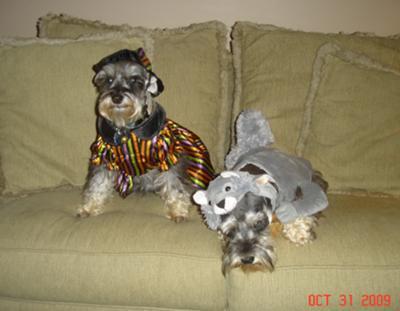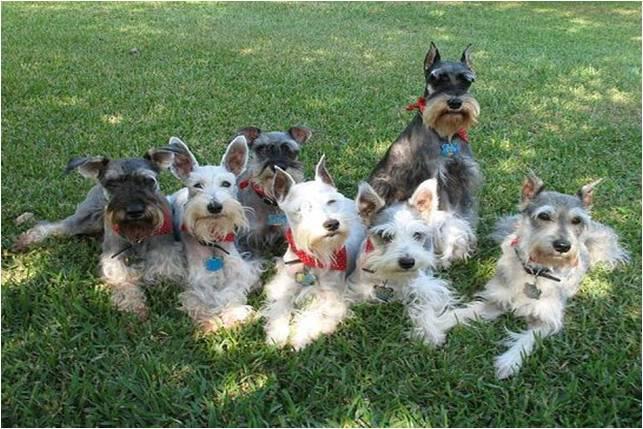The first image is the image on the left, the second image is the image on the right. Analyze the images presented: Is the assertion "A group of dogs is in the green grass in the image on the right." valid? Answer yes or no. Yes. The first image is the image on the left, the second image is the image on the right. Analyze the images presented: Is the assertion "Right image shows a group of schnauzers wearing colored collars." valid? Answer yes or no. Yes. 